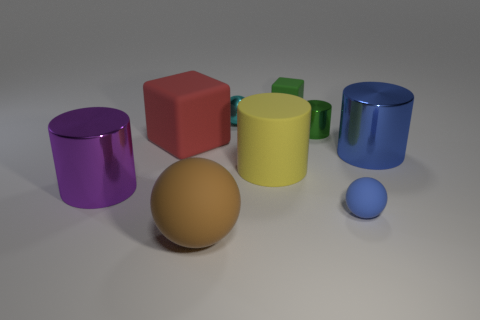What number of cylinders are on the left side of the big red rubber thing and right of the small matte cube? In the image provided, there is one cylinder on the left side of the big red cube and right of the small matte cube. This cylinder is purple in color. 